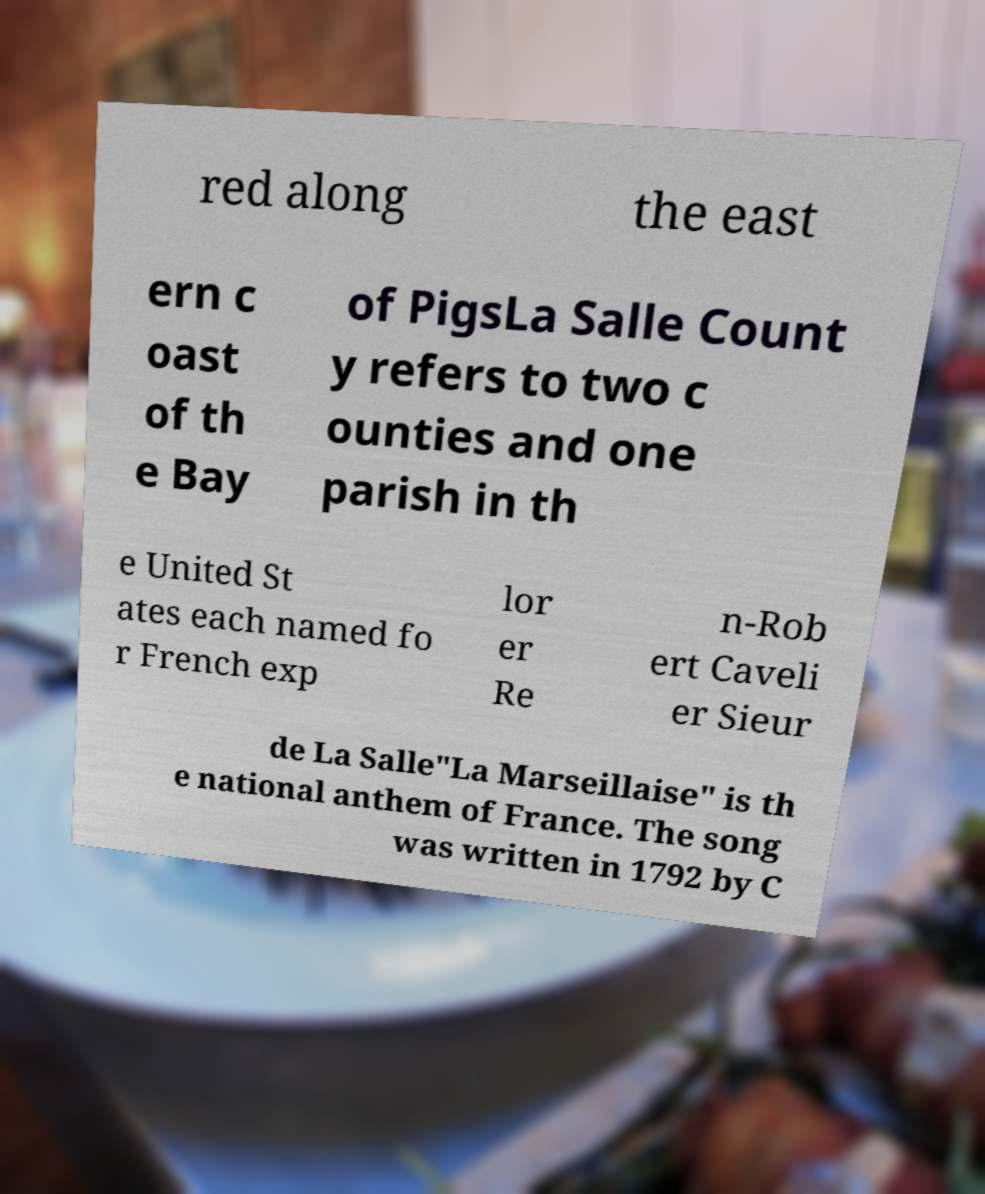Can you accurately transcribe the text from the provided image for me? red along the east ern c oast of th e Bay of PigsLa Salle Count y refers to two c ounties and one parish in th e United St ates each named fo r French exp lor er Re n-Rob ert Caveli er Sieur de La Salle"La Marseillaise" is th e national anthem of France. The song was written in 1792 by C 